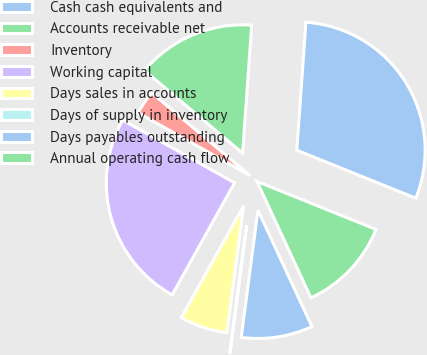<chart> <loc_0><loc_0><loc_500><loc_500><pie_chart><fcel>Cash cash equivalents and<fcel>Accounts receivable net<fcel>Inventory<fcel>Working capital<fcel>Days sales in accounts<fcel>Days of supply in inventory<fcel>Days payables outstanding<fcel>Annual operating cash flow<nl><fcel>29.97%<fcel>14.99%<fcel>3.0%<fcel>25.05%<fcel>6.0%<fcel>0.01%<fcel>8.99%<fcel>11.99%<nl></chart> 